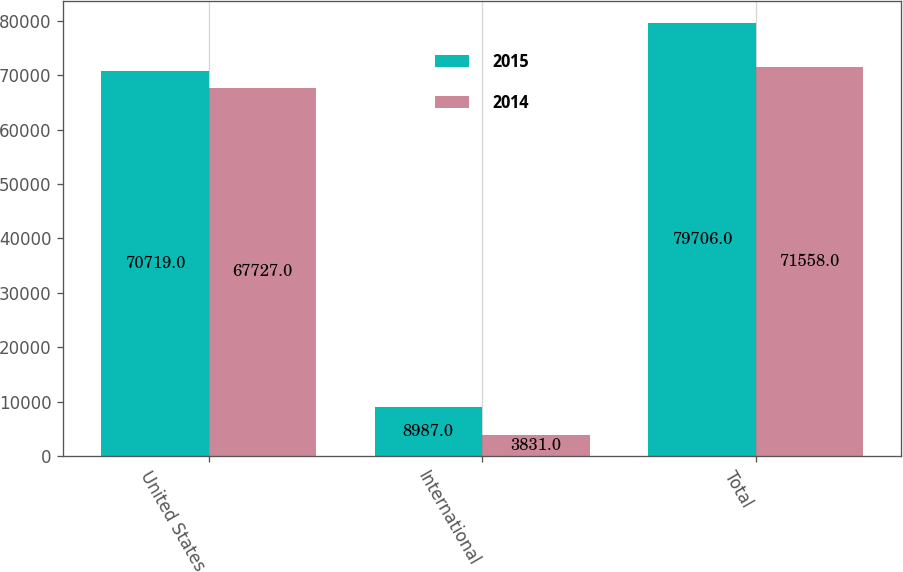Convert chart to OTSL. <chart><loc_0><loc_0><loc_500><loc_500><stacked_bar_chart><ecel><fcel>United States<fcel>International<fcel>Total<nl><fcel>2015<fcel>70719<fcel>8987<fcel>79706<nl><fcel>2014<fcel>67727<fcel>3831<fcel>71558<nl></chart> 